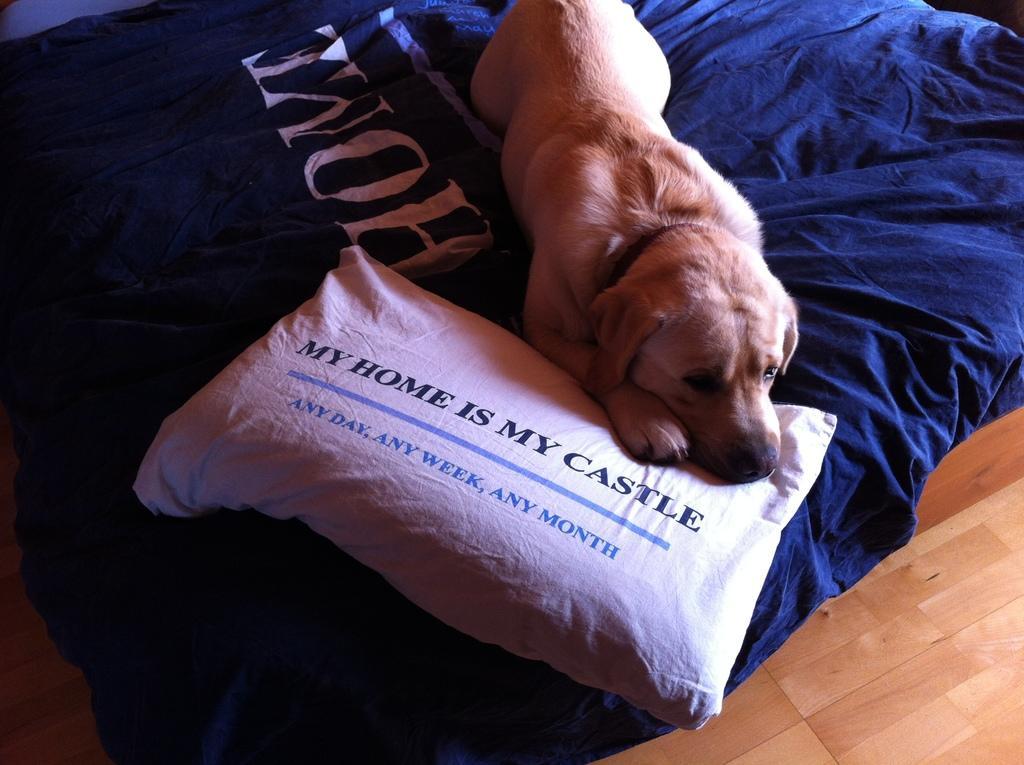Please provide a concise description of this image. In this picture we can see bed, pillow and dog. At the bottom it is floor. 